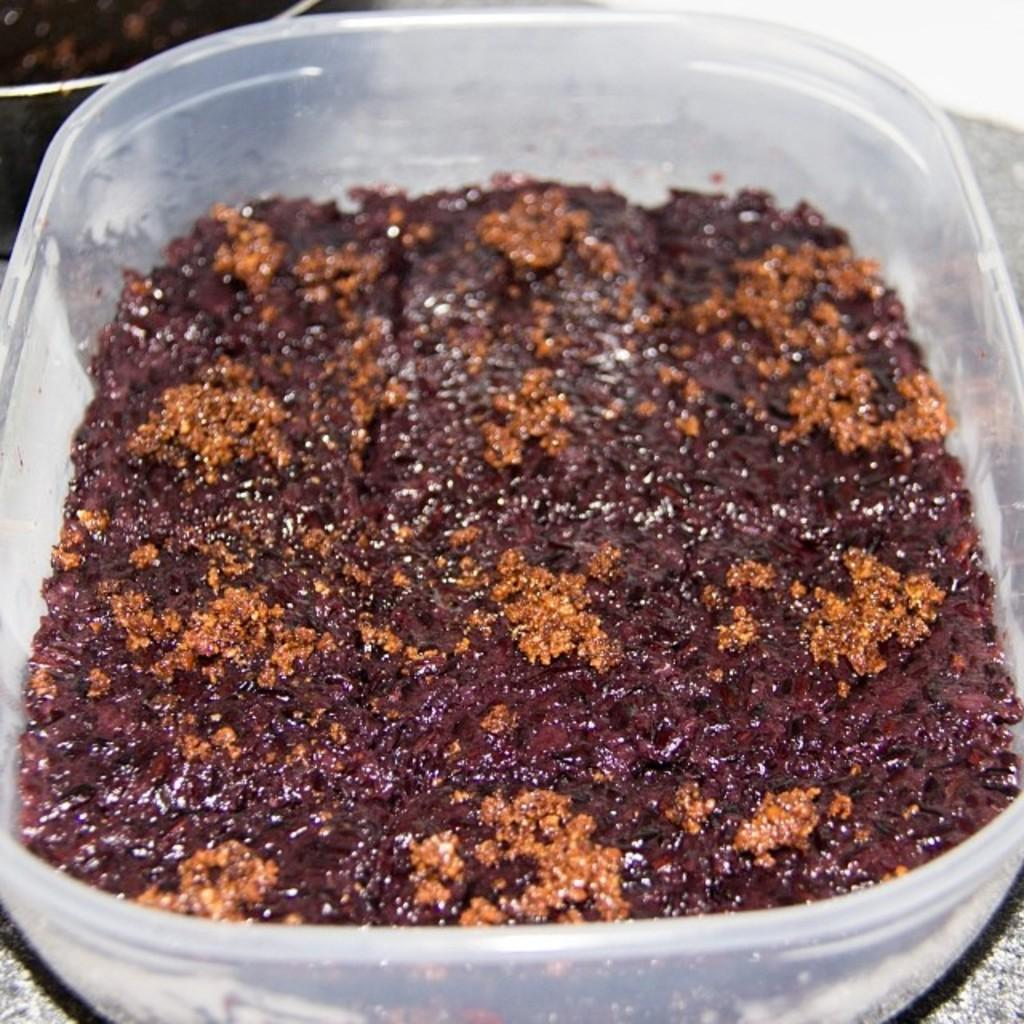What is contained within the plastic box in the image? There is a food item in the plastic box in the image. How many snakes are coiled around the plastic box in the image? There are no snakes present in the image; it only contains a food item in the plastic box. What type of fuel is being used to power the plastic box in the image? The plastic box is not powered by any fuel; it is a static object containing a food item. 